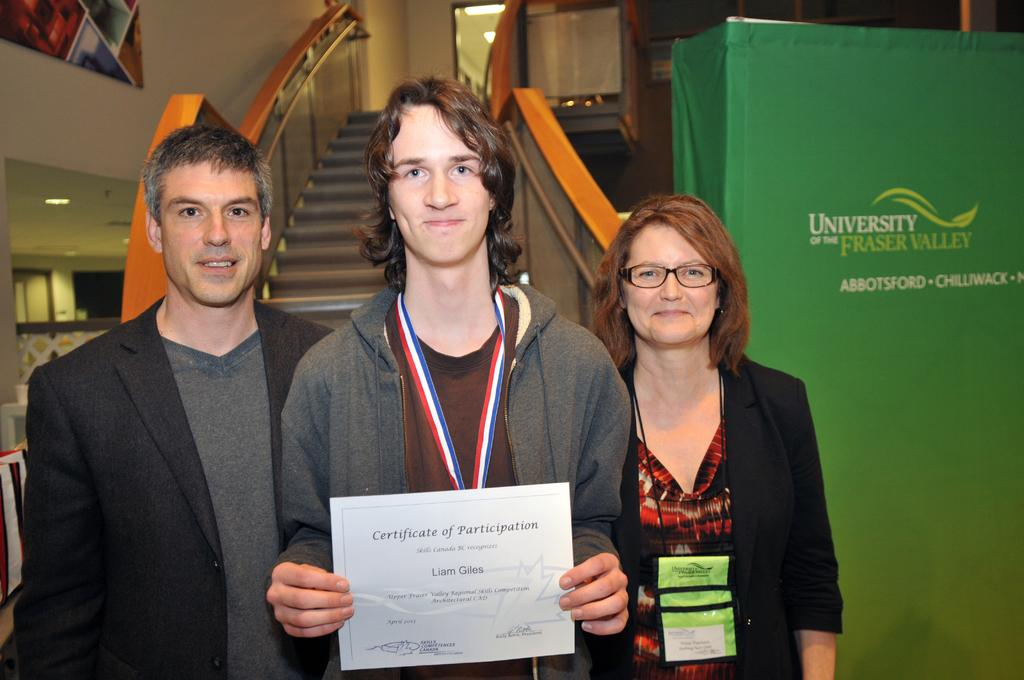<image>
Summarize the visual content of the image. A boy is holding up his Certificate of Participation for others to see. 